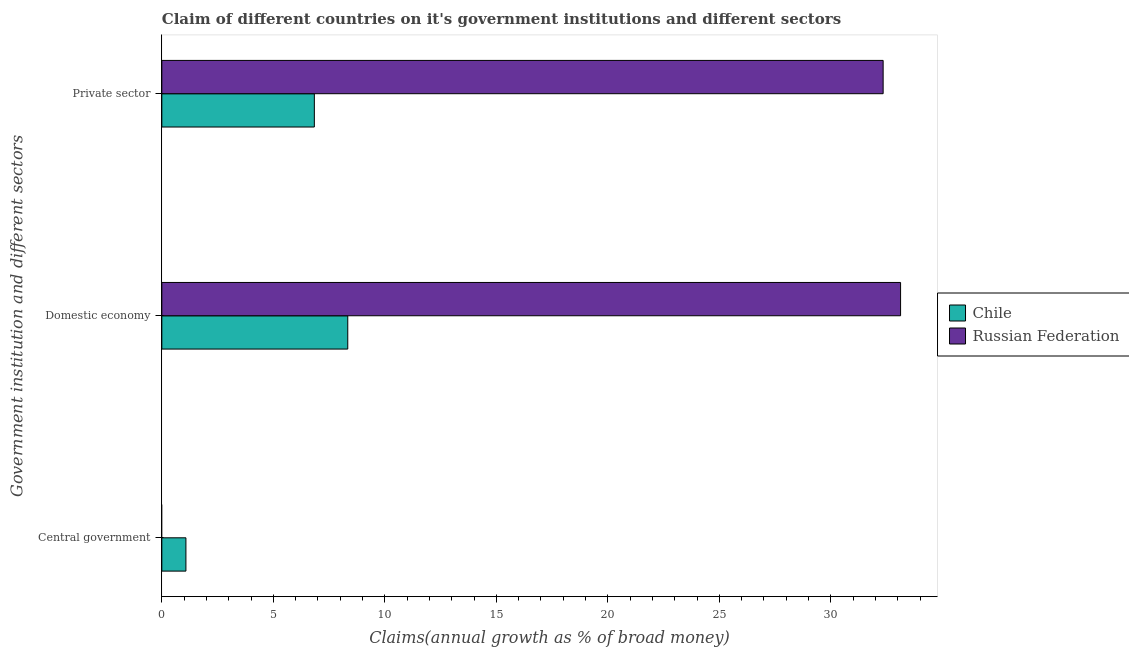How many different coloured bars are there?
Your answer should be compact. 2. Are the number of bars on each tick of the Y-axis equal?
Your answer should be compact. No. How many bars are there on the 1st tick from the top?
Your answer should be compact. 2. How many bars are there on the 1st tick from the bottom?
Your response must be concise. 1. What is the label of the 2nd group of bars from the top?
Your response must be concise. Domestic economy. What is the percentage of claim on the central government in Russian Federation?
Make the answer very short. 0. Across all countries, what is the maximum percentage of claim on the domestic economy?
Your response must be concise. 33.13. Across all countries, what is the minimum percentage of claim on the domestic economy?
Your response must be concise. 8.34. In which country was the percentage of claim on the private sector maximum?
Make the answer very short. Russian Federation. What is the total percentage of claim on the private sector in the graph?
Offer a very short reply. 39.18. What is the difference between the percentage of claim on the private sector in Russian Federation and that in Chile?
Your answer should be very brief. 25.51. What is the difference between the percentage of claim on the domestic economy in Russian Federation and the percentage of claim on the private sector in Chile?
Your response must be concise. 26.29. What is the average percentage of claim on the domestic economy per country?
Keep it short and to the point. 20.73. What is the difference between the percentage of claim on the domestic economy and percentage of claim on the central government in Chile?
Your response must be concise. 7.26. In how many countries, is the percentage of claim on the domestic economy greater than 19 %?
Offer a very short reply. 1. What is the ratio of the percentage of claim on the domestic economy in Chile to that in Russian Federation?
Ensure brevity in your answer.  0.25. Is the percentage of claim on the private sector in Russian Federation less than that in Chile?
Give a very brief answer. No. Is the difference between the percentage of claim on the domestic economy in Russian Federation and Chile greater than the difference between the percentage of claim on the private sector in Russian Federation and Chile?
Ensure brevity in your answer.  No. What is the difference between the highest and the second highest percentage of claim on the private sector?
Your response must be concise. 25.51. What is the difference between the highest and the lowest percentage of claim on the central government?
Offer a terse response. 1.08. Is it the case that in every country, the sum of the percentage of claim on the central government and percentage of claim on the domestic economy is greater than the percentage of claim on the private sector?
Offer a very short reply. Yes. How many bars are there?
Your answer should be compact. 5. Are all the bars in the graph horizontal?
Your answer should be very brief. Yes. Are the values on the major ticks of X-axis written in scientific E-notation?
Your answer should be very brief. No. How many legend labels are there?
Your response must be concise. 2. What is the title of the graph?
Offer a very short reply. Claim of different countries on it's government institutions and different sectors. Does "Albania" appear as one of the legend labels in the graph?
Offer a very short reply. No. What is the label or title of the X-axis?
Provide a succinct answer. Claims(annual growth as % of broad money). What is the label or title of the Y-axis?
Your response must be concise. Government institution and different sectors. What is the Claims(annual growth as % of broad money) of Chile in Central government?
Offer a very short reply. 1.08. What is the Claims(annual growth as % of broad money) of Chile in Domestic economy?
Your response must be concise. 8.34. What is the Claims(annual growth as % of broad money) in Russian Federation in Domestic economy?
Offer a very short reply. 33.13. What is the Claims(annual growth as % of broad money) in Chile in Private sector?
Your response must be concise. 6.84. What is the Claims(annual growth as % of broad money) in Russian Federation in Private sector?
Provide a short and direct response. 32.34. Across all Government institution and different sectors, what is the maximum Claims(annual growth as % of broad money) of Chile?
Offer a terse response. 8.34. Across all Government institution and different sectors, what is the maximum Claims(annual growth as % of broad money) of Russian Federation?
Ensure brevity in your answer.  33.13. Across all Government institution and different sectors, what is the minimum Claims(annual growth as % of broad money) in Chile?
Make the answer very short. 1.08. What is the total Claims(annual growth as % of broad money) of Chile in the graph?
Your answer should be very brief. 16.26. What is the total Claims(annual growth as % of broad money) in Russian Federation in the graph?
Offer a very short reply. 65.47. What is the difference between the Claims(annual growth as % of broad money) in Chile in Central government and that in Domestic economy?
Make the answer very short. -7.26. What is the difference between the Claims(annual growth as % of broad money) of Chile in Central government and that in Private sector?
Your answer should be compact. -5.76. What is the difference between the Claims(annual growth as % of broad money) in Chile in Domestic economy and that in Private sector?
Ensure brevity in your answer.  1.5. What is the difference between the Claims(annual growth as % of broad money) of Russian Federation in Domestic economy and that in Private sector?
Your answer should be very brief. 0.78. What is the difference between the Claims(annual growth as % of broad money) of Chile in Central government and the Claims(annual growth as % of broad money) of Russian Federation in Domestic economy?
Your answer should be compact. -32.05. What is the difference between the Claims(annual growth as % of broad money) of Chile in Central government and the Claims(annual growth as % of broad money) of Russian Federation in Private sector?
Offer a very short reply. -31.26. What is the difference between the Claims(annual growth as % of broad money) of Chile in Domestic economy and the Claims(annual growth as % of broad money) of Russian Federation in Private sector?
Keep it short and to the point. -24.01. What is the average Claims(annual growth as % of broad money) in Chile per Government institution and different sectors?
Your response must be concise. 5.42. What is the average Claims(annual growth as % of broad money) in Russian Federation per Government institution and different sectors?
Provide a succinct answer. 21.82. What is the difference between the Claims(annual growth as % of broad money) of Chile and Claims(annual growth as % of broad money) of Russian Federation in Domestic economy?
Your answer should be compact. -24.79. What is the difference between the Claims(annual growth as % of broad money) of Chile and Claims(annual growth as % of broad money) of Russian Federation in Private sector?
Your response must be concise. -25.51. What is the ratio of the Claims(annual growth as % of broad money) in Chile in Central government to that in Domestic economy?
Your answer should be compact. 0.13. What is the ratio of the Claims(annual growth as % of broad money) of Chile in Central government to that in Private sector?
Ensure brevity in your answer.  0.16. What is the ratio of the Claims(annual growth as % of broad money) in Chile in Domestic economy to that in Private sector?
Make the answer very short. 1.22. What is the ratio of the Claims(annual growth as % of broad money) of Russian Federation in Domestic economy to that in Private sector?
Keep it short and to the point. 1.02. What is the difference between the highest and the second highest Claims(annual growth as % of broad money) of Chile?
Provide a succinct answer. 1.5. What is the difference between the highest and the lowest Claims(annual growth as % of broad money) in Chile?
Your answer should be very brief. 7.26. What is the difference between the highest and the lowest Claims(annual growth as % of broad money) of Russian Federation?
Offer a very short reply. 33.13. 